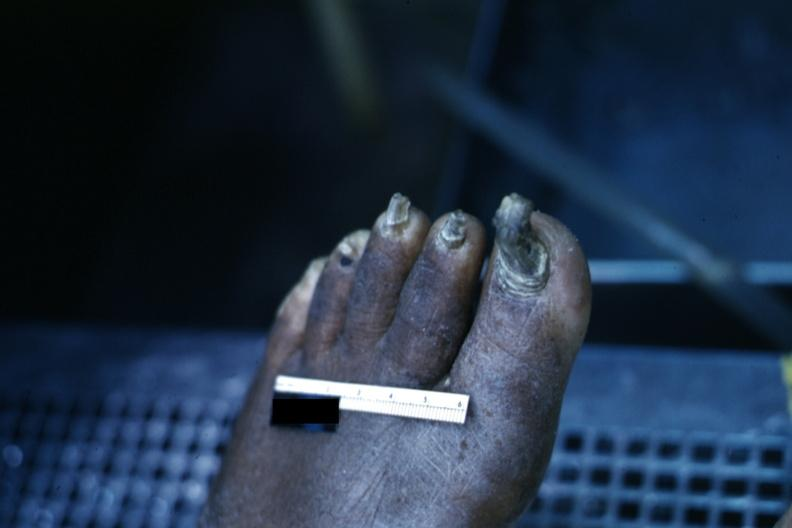does this image show distorted nails and thick skin typical of chronic ischemia?
Answer the question using a single word or phrase. Yes 